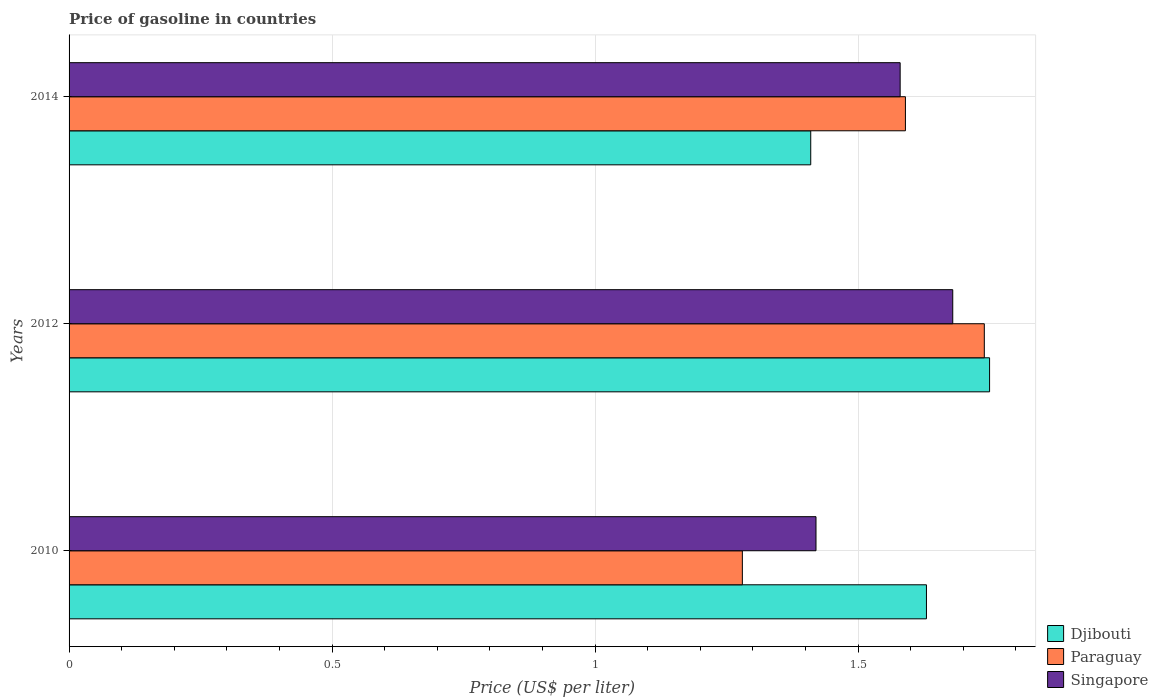How many different coloured bars are there?
Offer a very short reply. 3. Are the number of bars per tick equal to the number of legend labels?
Offer a terse response. Yes. How many bars are there on the 1st tick from the bottom?
Your answer should be compact. 3. What is the label of the 3rd group of bars from the top?
Offer a very short reply. 2010. In how many cases, is the number of bars for a given year not equal to the number of legend labels?
Your response must be concise. 0. What is the price of gasoline in Paraguay in 2012?
Your response must be concise. 1.74. Across all years, what is the maximum price of gasoline in Singapore?
Your response must be concise. 1.68. Across all years, what is the minimum price of gasoline in Djibouti?
Offer a very short reply. 1.41. In which year was the price of gasoline in Singapore maximum?
Your response must be concise. 2012. What is the total price of gasoline in Paraguay in the graph?
Provide a short and direct response. 4.61. What is the difference between the price of gasoline in Paraguay in 2010 and that in 2014?
Ensure brevity in your answer.  -0.31. What is the difference between the price of gasoline in Paraguay in 2010 and the price of gasoline in Singapore in 2014?
Ensure brevity in your answer.  -0.3. What is the average price of gasoline in Singapore per year?
Make the answer very short. 1.56. In the year 2010, what is the difference between the price of gasoline in Djibouti and price of gasoline in Singapore?
Offer a very short reply. 0.21. In how many years, is the price of gasoline in Paraguay greater than 1.6 US$?
Ensure brevity in your answer.  1. What is the ratio of the price of gasoline in Singapore in 2010 to that in 2014?
Your response must be concise. 0.9. Is the price of gasoline in Djibouti in 2010 less than that in 2012?
Give a very brief answer. Yes. Is the difference between the price of gasoline in Djibouti in 2012 and 2014 greater than the difference between the price of gasoline in Singapore in 2012 and 2014?
Offer a terse response. Yes. What is the difference between the highest and the second highest price of gasoline in Djibouti?
Offer a very short reply. 0.12. What is the difference between the highest and the lowest price of gasoline in Singapore?
Make the answer very short. 0.26. What does the 3rd bar from the top in 2012 represents?
Provide a short and direct response. Djibouti. What does the 3rd bar from the bottom in 2012 represents?
Make the answer very short. Singapore. Is it the case that in every year, the sum of the price of gasoline in Djibouti and price of gasoline in Paraguay is greater than the price of gasoline in Singapore?
Your answer should be compact. Yes. How many bars are there?
Your response must be concise. 9. Are all the bars in the graph horizontal?
Offer a very short reply. Yes. How many years are there in the graph?
Give a very brief answer. 3. Does the graph contain grids?
Your answer should be compact. Yes. Where does the legend appear in the graph?
Offer a terse response. Bottom right. What is the title of the graph?
Your response must be concise. Price of gasoline in countries. Does "Turkmenistan" appear as one of the legend labels in the graph?
Keep it short and to the point. No. What is the label or title of the X-axis?
Give a very brief answer. Price (US$ per liter). What is the label or title of the Y-axis?
Your response must be concise. Years. What is the Price (US$ per liter) of Djibouti in 2010?
Offer a terse response. 1.63. What is the Price (US$ per liter) in Paraguay in 2010?
Your answer should be compact. 1.28. What is the Price (US$ per liter) in Singapore in 2010?
Your response must be concise. 1.42. What is the Price (US$ per liter) of Paraguay in 2012?
Ensure brevity in your answer.  1.74. What is the Price (US$ per liter) of Singapore in 2012?
Provide a short and direct response. 1.68. What is the Price (US$ per liter) of Djibouti in 2014?
Provide a short and direct response. 1.41. What is the Price (US$ per liter) of Paraguay in 2014?
Ensure brevity in your answer.  1.59. What is the Price (US$ per liter) in Singapore in 2014?
Offer a terse response. 1.58. Across all years, what is the maximum Price (US$ per liter) in Paraguay?
Make the answer very short. 1.74. Across all years, what is the maximum Price (US$ per liter) of Singapore?
Offer a terse response. 1.68. Across all years, what is the minimum Price (US$ per liter) in Djibouti?
Your answer should be compact. 1.41. Across all years, what is the minimum Price (US$ per liter) in Paraguay?
Your response must be concise. 1.28. Across all years, what is the minimum Price (US$ per liter) of Singapore?
Your answer should be compact. 1.42. What is the total Price (US$ per liter) of Djibouti in the graph?
Offer a very short reply. 4.79. What is the total Price (US$ per liter) in Paraguay in the graph?
Make the answer very short. 4.61. What is the total Price (US$ per liter) of Singapore in the graph?
Offer a terse response. 4.68. What is the difference between the Price (US$ per liter) of Djibouti in 2010 and that in 2012?
Your answer should be very brief. -0.12. What is the difference between the Price (US$ per liter) in Paraguay in 2010 and that in 2012?
Your response must be concise. -0.46. What is the difference between the Price (US$ per liter) of Singapore in 2010 and that in 2012?
Your answer should be compact. -0.26. What is the difference between the Price (US$ per liter) in Djibouti in 2010 and that in 2014?
Make the answer very short. 0.22. What is the difference between the Price (US$ per liter) in Paraguay in 2010 and that in 2014?
Offer a terse response. -0.31. What is the difference between the Price (US$ per liter) of Singapore in 2010 and that in 2014?
Your response must be concise. -0.16. What is the difference between the Price (US$ per liter) of Djibouti in 2012 and that in 2014?
Your answer should be compact. 0.34. What is the difference between the Price (US$ per liter) in Djibouti in 2010 and the Price (US$ per liter) in Paraguay in 2012?
Provide a succinct answer. -0.11. What is the difference between the Price (US$ per liter) of Djibouti in 2010 and the Price (US$ per liter) of Singapore in 2014?
Offer a terse response. 0.05. What is the difference between the Price (US$ per liter) of Paraguay in 2010 and the Price (US$ per liter) of Singapore in 2014?
Offer a very short reply. -0.3. What is the difference between the Price (US$ per liter) of Djibouti in 2012 and the Price (US$ per liter) of Paraguay in 2014?
Provide a short and direct response. 0.16. What is the difference between the Price (US$ per liter) of Djibouti in 2012 and the Price (US$ per liter) of Singapore in 2014?
Make the answer very short. 0.17. What is the difference between the Price (US$ per liter) in Paraguay in 2012 and the Price (US$ per liter) in Singapore in 2014?
Offer a terse response. 0.16. What is the average Price (US$ per liter) in Djibouti per year?
Ensure brevity in your answer.  1.6. What is the average Price (US$ per liter) in Paraguay per year?
Your answer should be compact. 1.54. What is the average Price (US$ per liter) in Singapore per year?
Provide a succinct answer. 1.56. In the year 2010, what is the difference between the Price (US$ per liter) in Djibouti and Price (US$ per liter) in Paraguay?
Your response must be concise. 0.35. In the year 2010, what is the difference between the Price (US$ per liter) in Djibouti and Price (US$ per liter) in Singapore?
Provide a succinct answer. 0.21. In the year 2010, what is the difference between the Price (US$ per liter) of Paraguay and Price (US$ per liter) of Singapore?
Keep it short and to the point. -0.14. In the year 2012, what is the difference between the Price (US$ per liter) in Djibouti and Price (US$ per liter) in Paraguay?
Your answer should be very brief. 0.01. In the year 2012, what is the difference between the Price (US$ per liter) in Djibouti and Price (US$ per liter) in Singapore?
Provide a succinct answer. 0.07. In the year 2012, what is the difference between the Price (US$ per liter) of Paraguay and Price (US$ per liter) of Singapore?
Ensure brevity in your answer.  0.06. In the year 2014, what is the difference between the Price (US$ per liter) of Djibouti and Price (US$ per liter) of Paraguay?
Give a very brief answer. -0.18. In the year 2014, what is the difference between the Price (US$ per liter) of Djibouti and Price (US$ per liter) of Singapore?
Your response must be concise. -0.17. In the year 2014, what is the difference between the Price (US$ per liter) in Paraguay and Price (US$ per liter) in Singapore?
Give a very brief answer. 0.01. What is the ratio of the Price (US$ per liter) in Djibouti in 2010 to that in 2012?
Offer a terse response. 0.93. What is the ratio of the Price (US$ per liter) in Paraguay in 2010 to that in 2012?
Keep it short and to the point. 0.74. What is the ratio of the Price (US$ per liter) of Singapore in 2010 to that in 2012?
Make the answer very short. 0.85. What is the ratio of the Price (US$ per liter) of Djibouti in 2010 to that in 2014?
Provide a succinct answer. 1.16. What is the ratio of the Price (US$ per liter) in Paraguay in 2010 to that in 2014?
Provide a succinct answer. 0.81. What is the ratio of the Price (US$ per liter) in Singapore in 2010 to that in 2014?
Your answer should be compact. 0.9. What is the ratio of the Price (US$ per liter) in Djibouti in 2012 to that in 2014?
Keep it short and to the point. 1.24. What is the ratio of the Price (US$ per liter) of Paraguay in 2012 to that in 2014?
Your answer should be compact. 1.09. What is the ratio of the Price (US$ per liter) of Singapore in 2012 to that in 2014?
Provide a succinct answer. 1.06. What is the difference between the highest and the second highest Price (US$ per liter) of Djibouti?
Your answer should be very brief. 0.12. What is the difference between the highest and the second highest Price (US$ per liter) in Paraguay?
Ensure brevity in your answer.  0.15. What is the difference between the highest and the lowest Price (US$ per liter) of Djibouti?
Your answer should be very brief. 0.34. What is the difference between the highest and the lowest Price (US$ per liter) in Paraguay?
Give a very brief answer. 0.46. What is the difference between the highest and the lowest Price (US$ per liter) in Singapore?
Give a very brief answer. 0.26. 